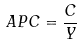Convert formula to latex. <formula><loc_0><loc_0><loc_500><loc_500>A P C = \frac { C } { Y }</formula> 